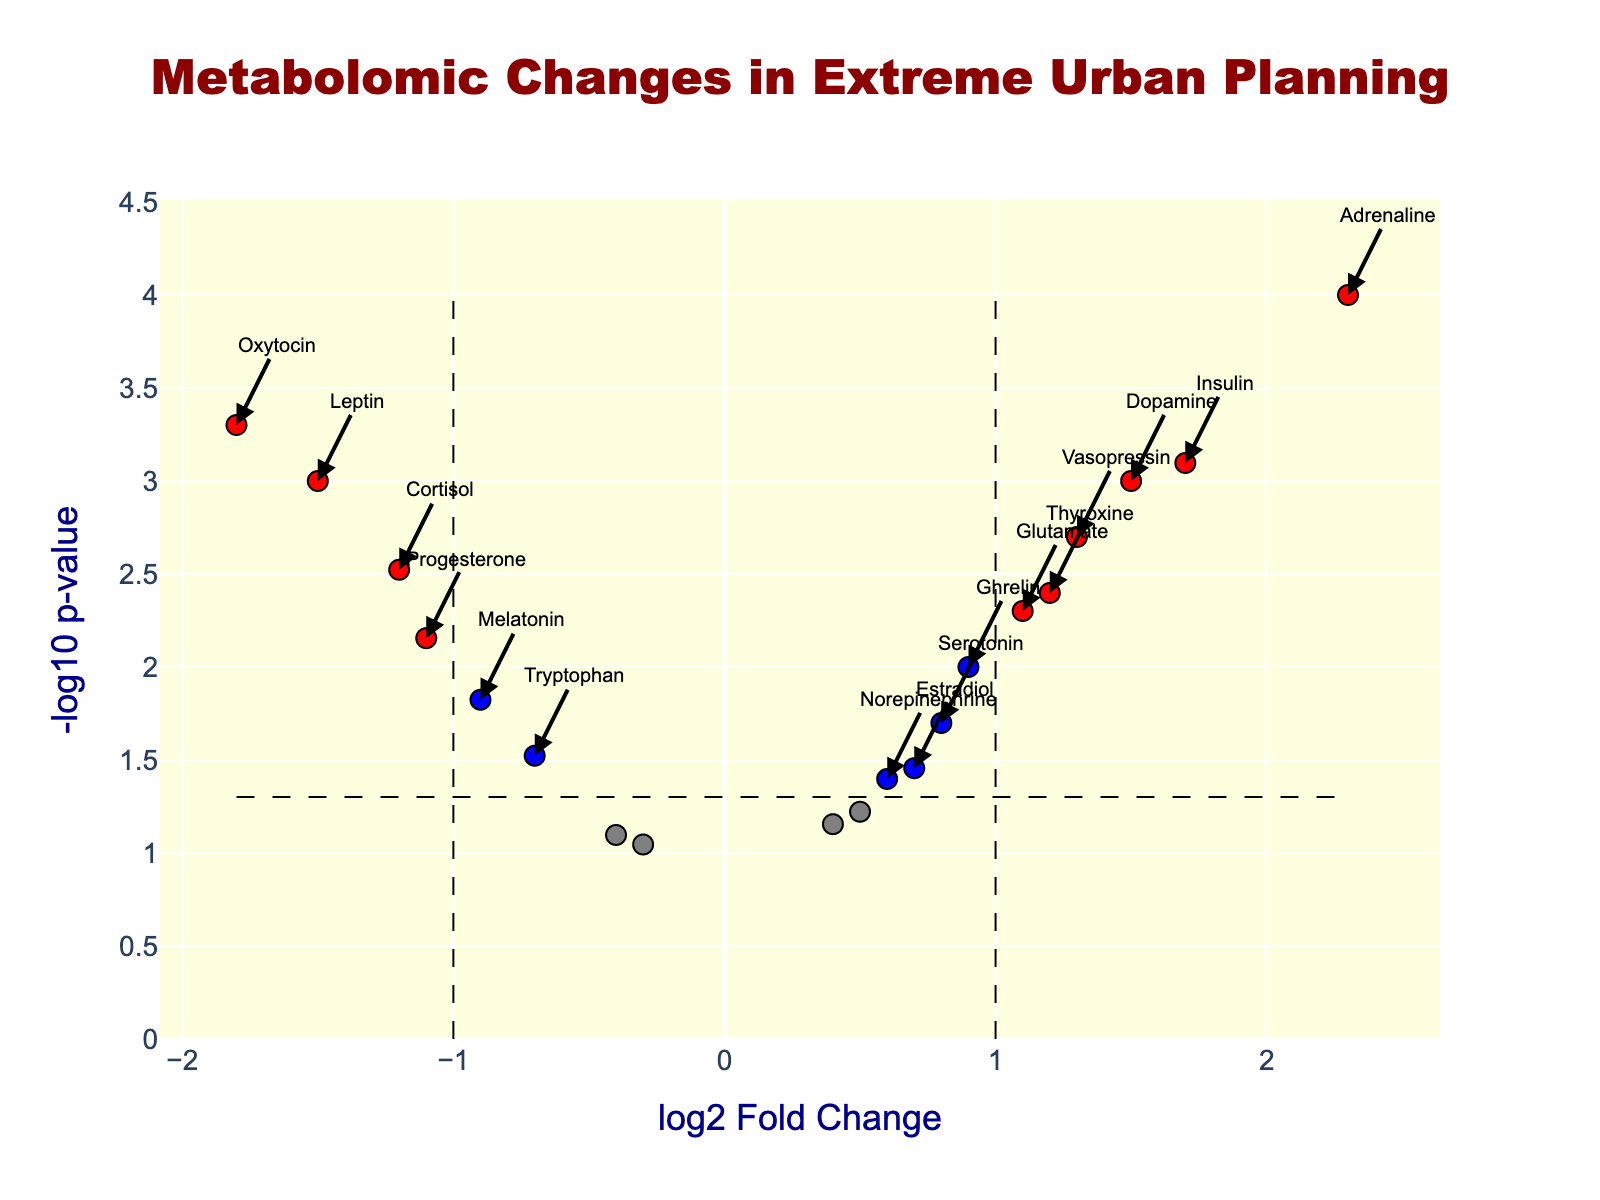what is the title of the plot? The title is usually located at the top center of the plot. In this case, it appears in a bold, large font and is colored dark red.
Answer: "Metabolomic Changes in Extreme Urban Planning" Which metabolite has the highest log2FoldChange? Locate the point farthest to the right on the x-axis. The hover text or annotation indicates "Adrenaline" with a log2FoldChange of 2.3.
Answer: Adrenaline How many metabolites have a p-value less than 0.05 and an absolute log2FoldChange greater than 1? Check points colored red, signifying those that meet both conditions. Annotated points include Adrenaline, Insulin, Vasopressin, Dopamine, Leptin, Oxytocin, and Cortisol.
Answer: 7 What are the log2FoldChange and the -log10(p-value) for Serotonin? Refer to the point labeled "Serotonin" in the plot, showing a log2FoldChange of 0.8 and -log10(p-value) calculated from the provided p-value 0.02. (-log10(0.02) ≈ 1.698).
Answer: 0.8 and 1.698 Which metabolites show a significant decrease in levels (negative log2FoldChange) with p-values below 0.05? Identify points to the left of the origin on the x-axis and have y-values (indicating significance) higher than the threshold line. Annotated points include Cortisol, Melatonin, Oxytocin, and Leptin.
Answer: Cortisol, Melatonin, Oxytocin, and Leptin What is the threshold for log2FoldChange used in this plot? Look at the dashed vertical lines dividing the x-axis. It's specified around ±1, the annotations guide you towards this threshold.
Answer: ±1 Among the metabolites with a positive log2FoldChange, which has the lowest p-value? Locate points to the right of the origin and identify one with the highest -log10(p-value), which indicates the lowest p-value. Adrenaline stands out with -log10(p-value) ≈ 4.
Answer: Adrenaline Is there any metabolite close to the p-value threshold of 0.05 but does not meet the significance criteria? Identify points near the dashed horizontal line at -log10(p-value)=1.301. Tyrosine and GABA are close but don't meet the threshold for significance.
Answer: Tyrosine, GABA 